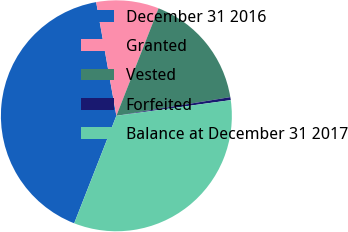Convert chart. <chart><loc_0><loc_0><loc_500><loc_500><pie_chart><fcel>December 31 2016<fcel>Granted<fcel>Vested<fcel>Forfeited<fcel>Balance at December 31 2017<nl><fcel>41.25%<fcel>8.75%<fcel>16.46%<fcel>0.42%<fcel>33.12%<nl></chart> 